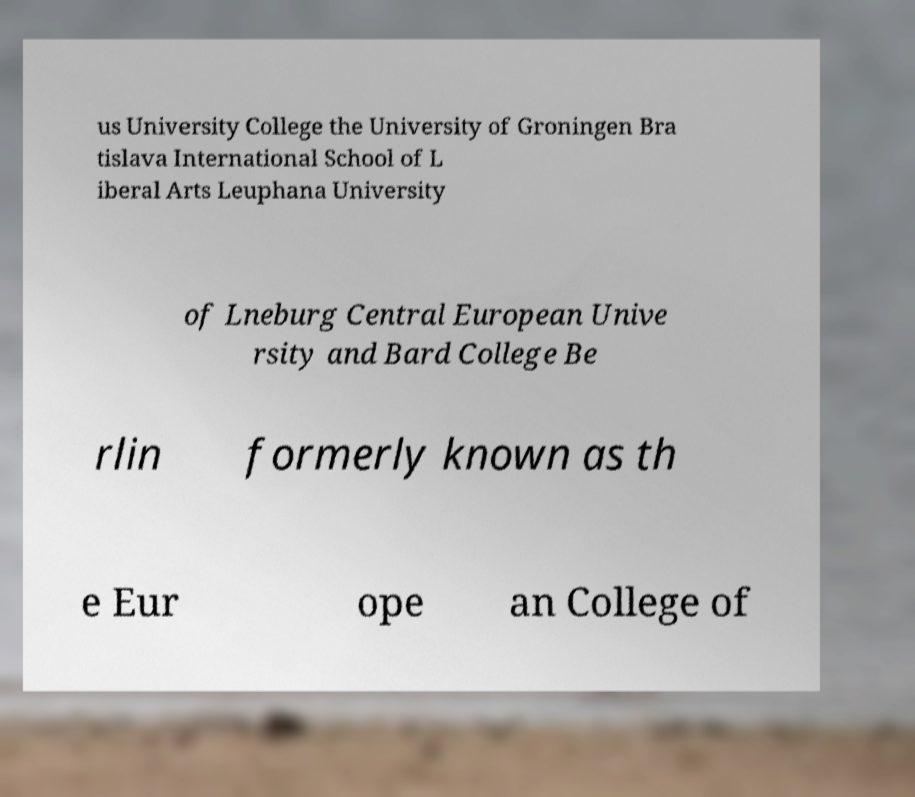Please read and relay the text visible in this image. What does it say? us University College the University of Groningen Bra tislava International School of L iberal Arts Leuphana University of Lneburg Central European Unive rsity and Bard College Be rlin formerly known as th e Eur ope an College of 